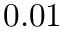<formula> <loc_0><loc_0><loc_500><loc_500>0 . 0 1</formula> 